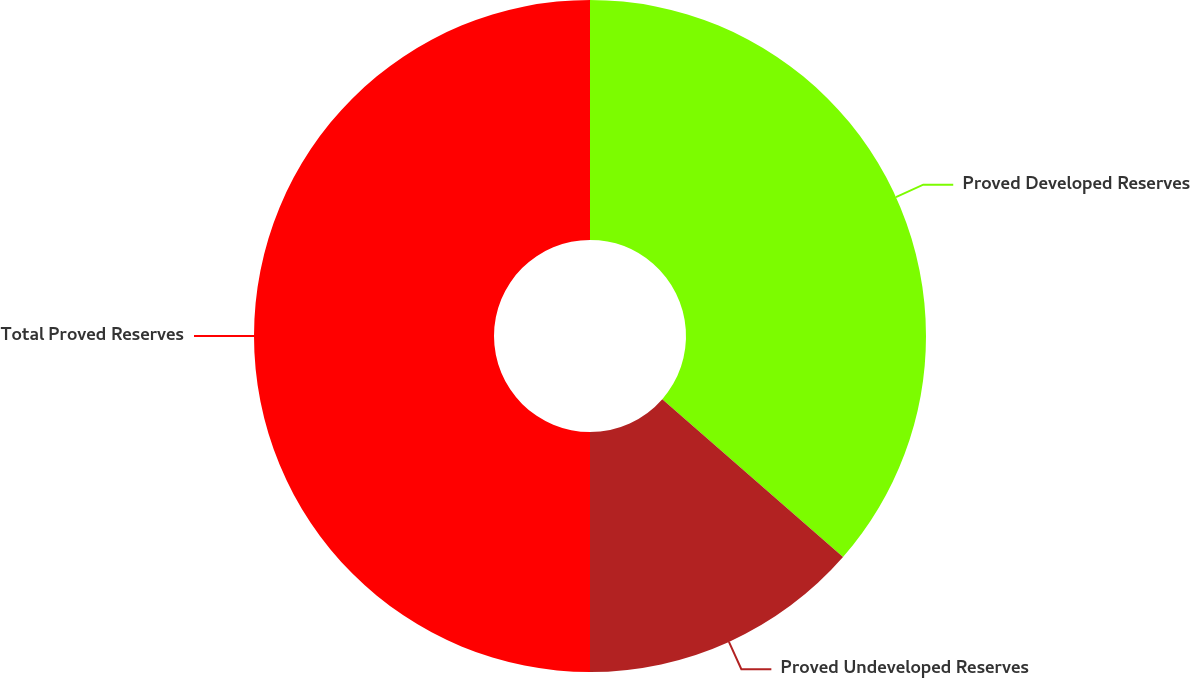Convert chart. <chart><loc_0><loc_0><loc_500><loc_500><pie_chart><fcel>Proved Developed Reserves<fcel>Proved Undeveloped Reserves<fcel>Total Proved Reserves<nl><fcel>36.43%<fcel>13.57%<fcel>50.0%<nl></chart> 